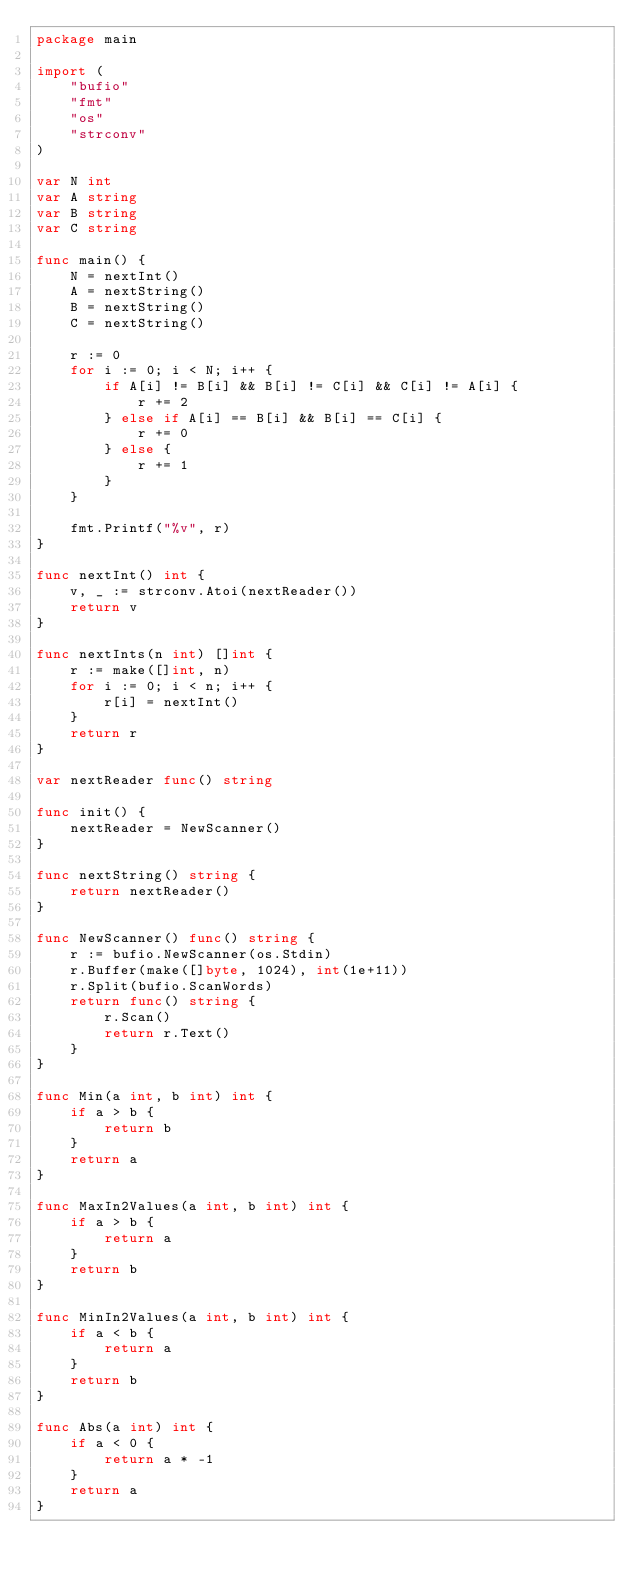Convert code to text. <code><loc_0><loc_0><loc_500><loc_500><_Go_>package main

import (
	"bufio"
	"fmt"
	"os"
	"strconv"
)

var N int
var A string
var B string
var C string

func main() {
	N = nextInt()
	A = nextString()
	B = nextString()
	C = nextString()

	r := 0
	for i := 0; i < N; i++ {
		if A[i] != B[i] && B[i] != C[i] && C[i] != A[i] {
			r += 2
		} else if A[i] == B[i] && B[i] == C[i] {
			r += 0
		} else {
			r += 1
		}
	}

	fmt.Printf("%v", r)
}

func nextInt() int {
	v, _ := strconv.Atoi(nextReader())
	return v
}

func nextInts(n int) []int {
	r := make([]int, n)
	for i := 0; i < n; i++ {
		r[i] = nextInt()
	}
	return r
}

var nextReader func() string

func init() {
	nextReader = NewScanner()
}

func nextString() string {
	return nextReader()
}

func NewScanner() func() string {
	r := bufio.NewScanner(os.Stdin)
	r.Buffer(make([]byte, 1024), int(1e+11))
	r.Split(bufio.ScanWords)
	return func() string {
		r.Scan()
		return r.Text()
	}
}

func Min(a int, b int) int {
	if a > b {
		return b
	}
	return a
}

func MaxIn2Values(a int, b int) int {
	if a > b {
		return a
	}
	return b
}

func MinIn2Values(a int, b int) int {
	if a < b {
		return a
	}
	return b
}

func Abs(a int) int {
	if a < 0 {
		return a * -1
	}
	return a
}
</code> 